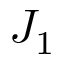<formula> <loc_0><loc_0><loc_500><loc_500>J _ { 1 }</formula> 